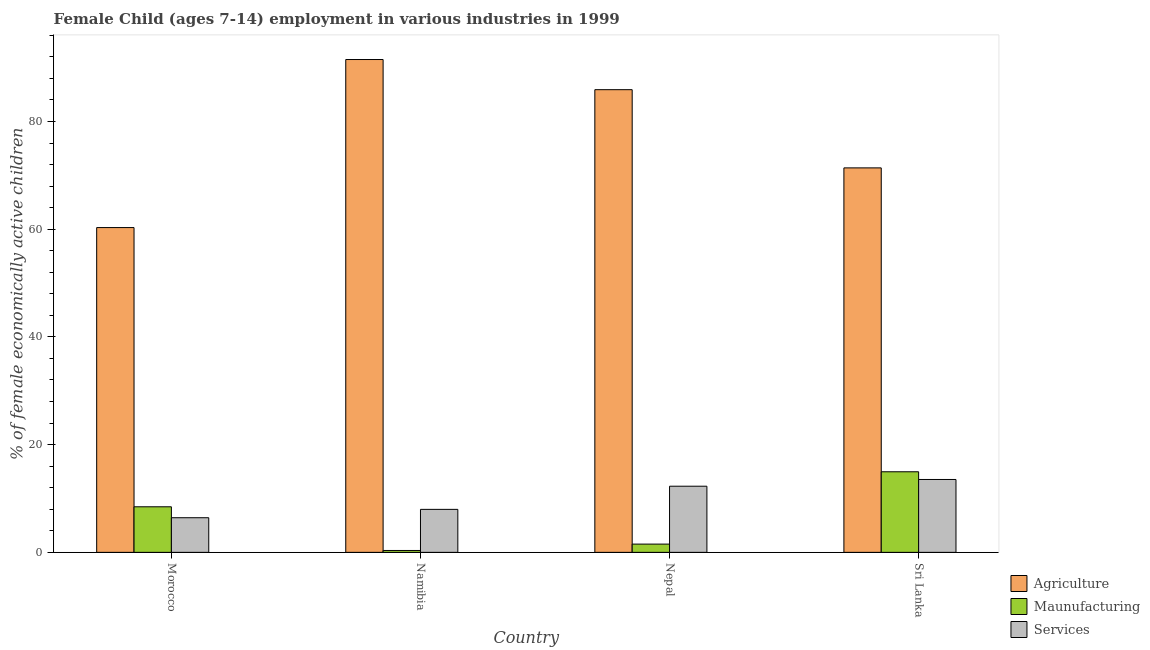How many different coloured bars are there?
Your answer should be very brief. 3. Are the number of bars per tick equal to the number of legend labels?
Ensure brevity in your answer.  Yes. Are the number of bars on each tick of the X-axis equal?
Ensure brevity in your answer.  Yes. How many bars are there on the 2nd tick from the right?
Give a very brief answer. 3. What is the label of the 2nd group of bars from the left?
Keep it short and to the point. Namibia. In how many cases, is the number of bars for a given country not equal to the number of legend labels?
Provide a short and direct response. 0. What is the percentage of economically active children in services in Morocco?
Give a very brief answer. 6.43. Across all countries, what is the maximum percentage of economically active children in manufacturing?
Your answer should be compact. 14.96. Across all countries, what is the minimum percentage of economically active children in agriculture?
Your answer should be very brief. 60.3. In which country was the percentage of economically active children in agriculture maximum?
Ensure brevity in your answer.  Namibia. In which country was the percentage of economically active children in manufacturing minimum?
Provide a succinct answer. Namibia. What is the total percentage of economically active children in services in the graph?
Provide a short and direct response. 40.22. What is the difference between the percentage of economically active children in services in Morocco and that in Namibia?
Your answer should be compact. -1.55. What is the difference between the percentage of economically active children in agriculture in Sri Lanka and the percentage of economically active children in services in Nepal?
Make the answer very short. 59.1. What is the average percentage of economically active children in services per country?
Your answer should be compact. 10.05. What is the difference between the percentage of economically active children in manufacturing and percentage of economically active children in services in Morocco?
Provide a succinct answer. 2.03. What is the ratio of the percentage of economically active children in services in Nepal to that in Sri Lanka?
Provide a short and direct response. 0.91. Is the percentage of economically active children in agriculture in Morocco less than that in Sri Lanka?
Your response must be concise. Yes. What is the difference between the highest and the lowest percentage of economically active children in manufacturing?
Provide a short and direct response. 14.61. In how many countries, is the percentage of economically active children in manufacturing greater than the average percentage of economically active children in manufacturing taken over all countries?
Your response must be concise. 2. Is the sum of the percentage of economically active children in agriculture in Morocco and Namibia greater than the maximum percentage of economically active children in manufacturing across all countries?
Ensure brevity in your answer.  Yes. What does the 1st bar from the left in Nepal represents?
Provide a succinct answer. Agriculture. What does the 3rd bar from the right in Sri Lanka represents?
Your answer should be compact. Agriculture. Is it the case that in every country, the sum of the percentage of economically active children in agriculture and percentage of economically active children in manufacturing is greater than the percentage of economically active children in services?
Make the answer very short. Yes. How many countries are there in the graph?
Offer a very short reply. 4. Are the values on the major ticks of Y-axis written in scientific E-notation?
Offer a very short reply. No. Does the graph contain any zero values?
Provide a succinct answer. No. Where does the legend appear in the graph?
Provide a short and direct response. Bottom right. How are the legend labels stacked?
Your answer should be compact. Vertical. What is the title of the graph?
Offer a terse response. Female Child (ages 7-14) employment in various industries in 1999. Does "Industrial Nitrous Oxide" appear as one of the legend labels in the graph?
Offer a terse response. No. What is the label or title of the Y-axis?
Your answer should be very brief. % of female economically active children. What is the % of female economically active children of Agriculture in Morocco?
Provide a short and direct response. 60.3. What is the % of female economically active children of Maunufacturing in Morocco?
Keep it short and to the point. 8.46. What is the % of female economically active children of Services in Morocco?
Keep it short and to the point. 6.43. What is the % of female economically active children in Agriculture in Namibia?
Offer a terse response. 91.5. What is the % of female economically active children in Maunufacturing in Namibia?
Make the answer very short. 0.35. What is the % of female economically active children in Services in Namibia?
Give a very brief answer. 7.98. What is the % of female economically active children of Agriculture in Nepal?
Ensure brevity in your answer.  85.9. What is the % of female economically active children in Maunufacturing in Nepal?
Your answer should be compact. 1.53. What is the % of female economically active children of Services in Nepal?
Your answer should be compact. 12.28. What is the % of female economically active children of Agriculture in Sri Lanka?
Offer a very short reply. 71.38. What is the % of female economically active children of Maunufacturing in Sri Lanka?
Make the answer very short. 14.96. What is the % of female economically active children in Services in Sri Lanka?
Provide a short and direct response. 13.53. Across all countries, what is the maximum % of female economically active children in Agriculture?
Provide a succinct answer. 91.5. Across all countries, what is the maximum % of female economically active children of Maunufacturing?
Provide a succinct answer. 14.96. Across all countries, what is the maximum % of female economically active children in Services?
Make the answer very short. 13.53. Across all countries, what is the minimum % of female economically active children in Agriculture?
Your response must be concise. 60.3. Across all countries, what is the minimum % of female economically active children of Services?
Offer a terse response. 6.43. What is the total % of female economically active children in Agriculture in the graph?
Provide a short and direct response. 309.08. What is the total % of female economically active children in Maunufacturing in the graph?
Offer a very short reply. 25.3. What is the total % of female economically active children in Services in the graph?
Your answer should be compact. 40.22. What is the difference between the % of female economically active children in Agriculture in Morocco and that in Namibia?
Provide a short and direct response. -31.2. What is the difference between the % of female economically active children of Maunufacturing in Morocco and that in Namibia?
Keep it short and to the point. 8.11. What is the difference between the % of female economically active children of Services in Morocco and that in Namibia?
Offer a terse response. -1.55. What is the difference between the % of female economically active children in Agriculture in Morocco and that in Nepal?
Keep it short and to the point. -25.6. What is the difference between the % of female economically active children of Maunufacturing in Morocco and that in Nepal?
Offer a very short reply. 6.93. What is the difference between the % of female economically active children in Services in Morocco and that in Nepal?
Provide a succinct answer. -5.85. What is the difference between the % of female economically active children of Agriculture in Morocco and that in Sri Lanka?
Provide a short and direct response. -11.08. What is the difference between the % of female economically active children of Maunufacturing in Morocco and that in Sri Lanka?
Your response must be concise. -6.5. What is the difference between the % of female economically active children of Agriculture in Namibia and that in Nepal?
Make the answer very short. 5.6. What is the difference between the % of female economically active children of Maunufacturing in Namibia and that in Nepal?
Make the answer very short. -1.18. What is the difference between the % of female economically active children in Agriculture in Namibia and that in Sri Lanka?
Your response must be concise. 20.12. What is the difference between the % of female economically active children in Maunufacturing in Namibia and that in Sri Lanka?
Give a very brief answer. -14.61. What is the difference between the % of female economically active children in Services in Namibia and that in Sri Lanka?
Provide a succinct answer. -5.55. What is the difference between the % of female economically active children in Agriculture in Nepal and that in Sri Lanka?
Ensure brevity in your answer.  14.52. What is the difference between the % of female economically active children of Maunufacturing in Nepal and that in Sri Lanka?
Provide a succinct answer. -13.43. What is the difference between the % of female economically active children in Services in Nepal and that in Sri Lanka?
Give a very brief answer. -1.25. What is the difference between the % of female economically active children of Agriculture in Morocco and the % of female economically active children of Maunufacturing in Namibia?
Give a very brief answer. 59.95. What is the difference between the % of female economically active children in Agriculture in Morocco and the % of female economically active children in Services in Namibia?
Offer a very short reply. 52.32. What is the difference between the % of female economically active children of Maunufacturing in Morocco and the % of female economically active children of Services in Namibia?
Give a very brief answer. 0.48. What is the difference between the % of female economically active children in Agriculture in Morocco and the % of female economically active children in Maunufacturing in Nepal?
Make the answer very short. 58.77. What is the difference between the % of female economically active children of Agriculture in Morocco and the % of female economically active children of Services in Nepal?
Offer a very short reply. 48.02. What is the difference between the % of female economically active children of Maunufacturing in Morocco and the % of female economically active children of Services in Nepal?
Your answer should be very brief. -3.82. What is the difference between the % of female economically active children in Agriculture in Morocco and the % of female economically active children in Maunufacturing in Sri Lanka?
Give a very brief answer. 45.34. What is the difference between the % of female economically active children in Agriculture in Morocco and the % of female economically active children in Services in Sri Lanka?
Your answer should be compact. 46.77. What is the difference between the % of female economically active children of Maunufacturing in Morocco and the % of female economically active children of Services in Sri Lanka?
Ensure brevity in your answer.  -5.07. What is the difference between the % of female economically active children of Agriculture in Namibia and the % of female economically active children of Maunufacturing in Nepal?
Keep it short and to the point. 89.97. What is the difference between the % of female economically active children of Agriculture in Namibia and the % of female economically active children of Services in Nepal?
Provide a short and direct response. 79.22. What is the difference between the % of female economically active children in Maunufacturing in Namibia and the % of female economically active children in Services in Nepal?
Offer a terse response. -11.93. What is the difference between the % of female economically active children in Agriculture in Namibia and the % of female economically active children in Maunufacturing in Sri Lanka?
Your answer should be very brief. 76.54. What is the difference between the % of female economically active children of Agriculture in Namibia and the % of female economically active children of Services in Sri Lanka?
Offer a terse response. 77.97. What is the difference between the % of female economically active children in Maunufacturing in Namibia and the % of female economically active children in Services in Sri Lanka?
Ensure brevity in your answer.  -13.18. What is the difference between the % of female economically active children in Agriculture in Nepal and the % of female economically active children in Maunufacturing in Sri Lanka?
Your answer should be very brief. 70.94. What is the difference between the % of female economically active children in Agriculture in Nepal and the % of female economically active children in Services in Sri Lanka?
Provide a short and direct response. 72.37. What is the difference between the % of female economically active children of Maunufacturing in Nepal and the % of female economically active children of Services in Sri Lanka?
Your answer should be compact. -12. What is the average % of female economically active children of Agriculture per country?
Provide a succinct answer. 77.27. What is the average % of female economically active children in Maunufacturing per country?
Offer a very short reply. 6.33. What is the average % of female economically active children in Services per country?
Your response must be concise. 10.05. What is the difference between the % of female economically active children in Agriculture and % of female economically active children in Maunufacturing in Morocco?
Keep it short and to the point. 51.84. What is the difference between the % of female economically active children in Agriculture and % of female economically active children in Services in Morocco?
Give a very brief answer. 53.87. What is the difference between the % of female economically active children in Maunufacturing and % of female economically active children in Services in Morocco?
Offer a terse response. 2.03. What is the difference between the % of female economically active children in Agriculture and % of female economically active children in Maunufacturing in Namibia?
Ensure brevity in your answer.  91.15. What is the difference between the % of female economically active children in Agriculture and % of female economically active children in Services in Namibia?
Keep it short and to the point. 83.52. What is the difference between the % of female economically active children in Maunufacturing and % of female economically active children in Services in Namibia?
Ensure brevity in your answer.  -7.63. What is the difference between the % of female economically active children in Agriculture and % of female economically active children in Maunufacturing in Nepal?
Provide a short and direct response. 84.37. What is the difference between the % of female economically active children of Agriculture and % of female economically active children of Services in Nepal?
Your response must be concise. 73.62. What is the difference between the % of female economically active children of Maunufacturing and % of female economically active children of Services in Nepal?
Give a very brief answer. -10.75. What is the difference between the % of female economically active children of Agriculture and % of female economically active children of Maunufacturing in Sri Lanka?
Provide a short and direct response. 56.42. What is the difference between the % of female economically active children in Agriculture and % of female economically active children in Services in Sri Lanka?
Provide a short and direct response. 57.85. What is the difference between the % of female economically active children of Maunufacturing and % of female economically active children of Services in Sri Lanka?
Give a very brief answer. 1.43. What is the ratio of the % of female economically active children of Agriculture in Morocco to that in Namibia?
Provide a short and direct response. 0.66. What is the ratio of the % of female economically active children of Maunufacturing in Morocco to that in Namibia?
Provide a short and direct response. 24.17. What is the ratio of the % of female economically active children in Services in Morocco to that in Namibia?
Provide a succinct answer. 0.81. What is the ratio of the % of female economically active children in Agriculture in Morocco to that in Nepal?
Your response must be concise. 0.7. What is the ratio of the % of female economically active children of Maunufacturing in Morocco to that in Nepal?
Your answer should be compact. 5.52. What is the ratio of the % of female economically active children in Services in Morocco to that in Nepal?
Your response must be concise. 0.52. What is the ratio of the % of female economically active children in Agriculture in Morocco to that in Sri Lanka?
Provide a succinct answer. 0.84. What is the ratio of the % of female economically active children of Maunufacturing in Morocco to that in Sri Lanka?
Ensure brevity in your answer.  0.57. What is the ratio of the % of female economically active children of Services in Morocco to that in Sri Lanka?
Provide a short and direct response. 0.48. What is the ratio of the % of female economically active children in Agriculture in Namibia to that in Nepal?
Your answer should be very brief. 1.07. What is the ratio of the % of female economically active children of Maunufacturing in Namibia to that in Nepal?
Keep it short and to the point. 0.23. What is the ratio of the % of female economically active children of Services in Namibia to that in Nepal?
Provide a short and direct response. 0.65. What is the ratio of the % of female economically active children in Agriculture in Namibia to that in Sri Lanka?
Your response must be concise. 1.28. What is the ratio of the % of female economically active children of Maunufacturing in Namibia to that in Sri Lanka?
Give a very brief answer. 0.02. What is the ratio of the % of female economically active children in Services in Namibia to that in Sri Lanka?
Offer a very short reply. 0.59. What is the ratio of the % of female economically active children in Agriculture in Nepal to that in Sri Lanka?
Keep it short and to the point. 1.2. What is the ratio of the % of female economically active children in Maunufacturing in Nepal to that in Sri Lanka?
Your response must be concise. 0.1. What is the ratio of the % of female economically active children of Services in Nepal to that in Sri Lanka?
Ensure brevity in your answer.  0.91. What is the difference between the highest and the second highest % of female economically active children of Agriculture?
Offer a very short reply. 5.6. What is the difference between the highest and the second highest % of female economically active children of Maunufacturing?
Your answer should be compact. 6.5. What is the difference between the highest and the lowest % of female economically active children of Agriculture?
Your answer should be compact. 31.2. What is the difference between the highest and the lowest % of female economically active children of Maunufacturing?
Provide a short and direct response. 14.61. What is the difference between the highest and the lowest % of female economically active children of Services?
Give a very brief answer. 7.1. 